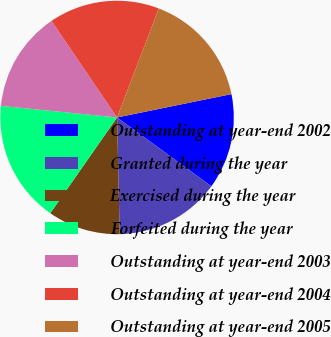Convert chart to OTSL. <chart><loc_0><loc_0><loc_500><loc_500><pie_chart><fcel>Outstanding at year-end 2002<fcel>Granted during the year<fcel>Exercised during the year<fcel>Forfeited during the year<fcel>Outstanding at year-end 2003<fcel>Outstanding at year-end 2004<fcel>Outstanding at year-end 2005<nl><fcel>13.24%<fcel>14.61%<fcel>10.05%<fcel>16.89%<fcel>13.93%<fcel>15.3%<fcel>15.98%<nl></chart> 